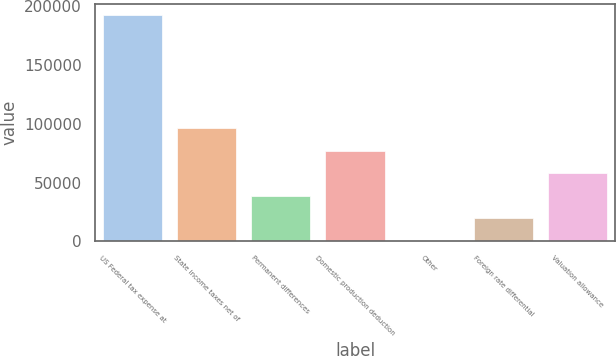Convert chart. <chart><loc_0><loc_0><loc_500><loc_500><bar_chart><fcel>US Federal tax expense at<fcel>State income taxes net of<fcel>Permanent differences<fcel>Domestic production deduction<fcel>Other<fcel>Foreign rate differential<fcel>Valuation allowance<nl><fcel>192204<fcel>96296<fcel>38751.2<fcel>77114.4<fcel>388<fcel>19569.6<fcel>57932.8<nl></chart> 